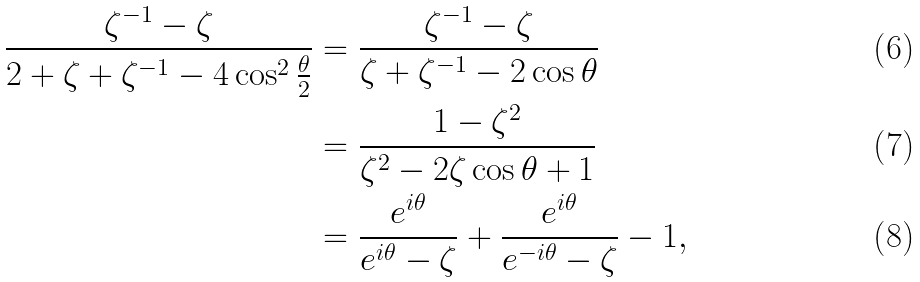Convert formula to latex. <formula><loc_0><loc_0><loc_500><loc_500>\frac { \zeta ^ { - 1 } - \zeta } { 2 + \zeta + \zeta ^ { - 1 } - 4 \cos ^ { 2 } \frac { \theta } { 2 } } & = \frac { \zeta ^ { - 1 } - \zeta } { \zeta + \zeta ^ { - 1 } - 2 \cos \theta } \\ & = \frac { 1 - \zeta ^ { 2 } } { \zeta ^ { 2 } - 2 \zeta \cos \theta + 1 } \\ & = \frac { e ^ { i \theta } } { e ^ { i \theta } - \zeta } + \frac { e ^ { i \theta } } { e ^ { - i \theta } - \zeta } - 1 ,</formula> 